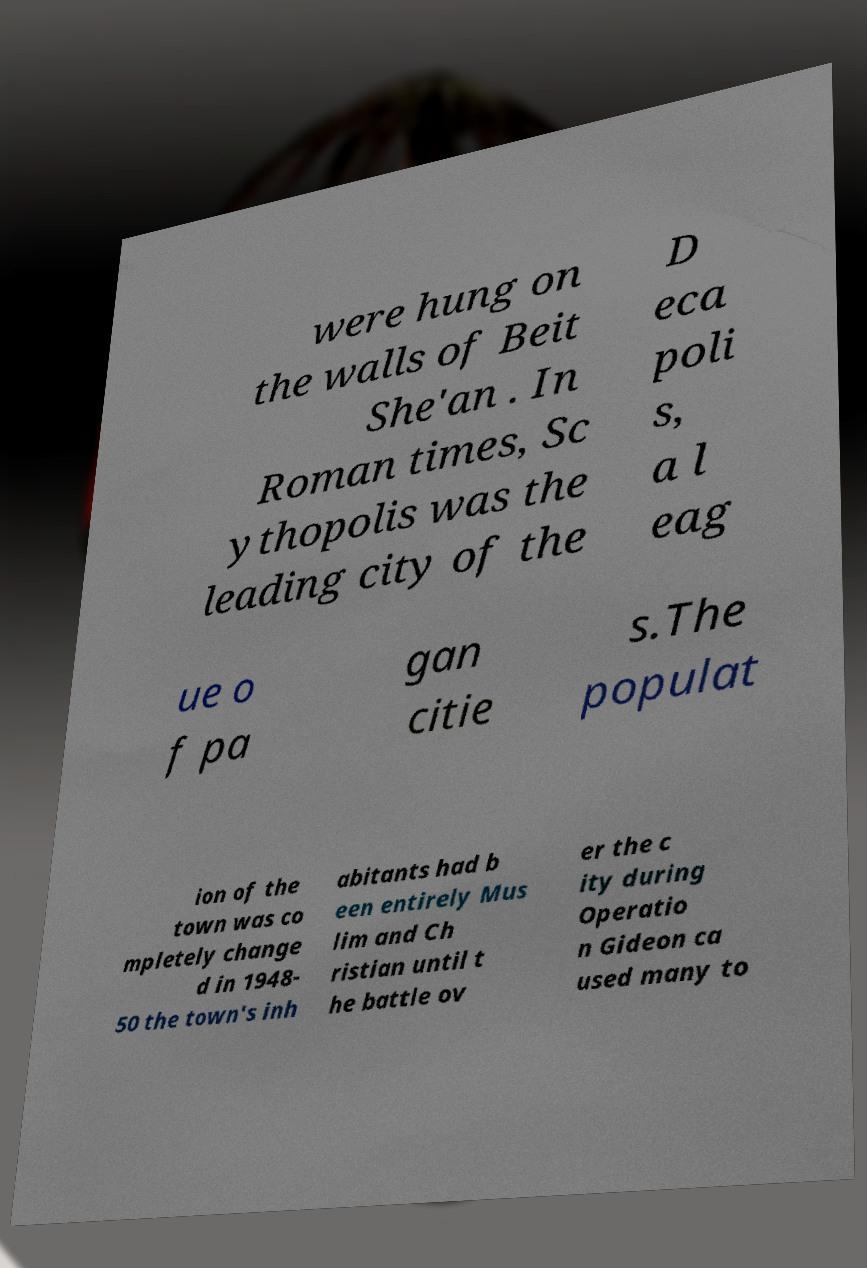There's text embedded in this image that I need extracted. Can you transcribe it verbatim? were hung on the walls of Beit She'an . In Roman times, Sc ythopolis was the leading city of the D eca poli s, a l eag ue o f pa gan citie s.The populat ion of the town was co mpletely change d in 1948- 50 the town's inh abitants had b een entirely Mus lim and Ch ristian until t he battle ov er the c ity during Operatio n Gideon ca used many to 